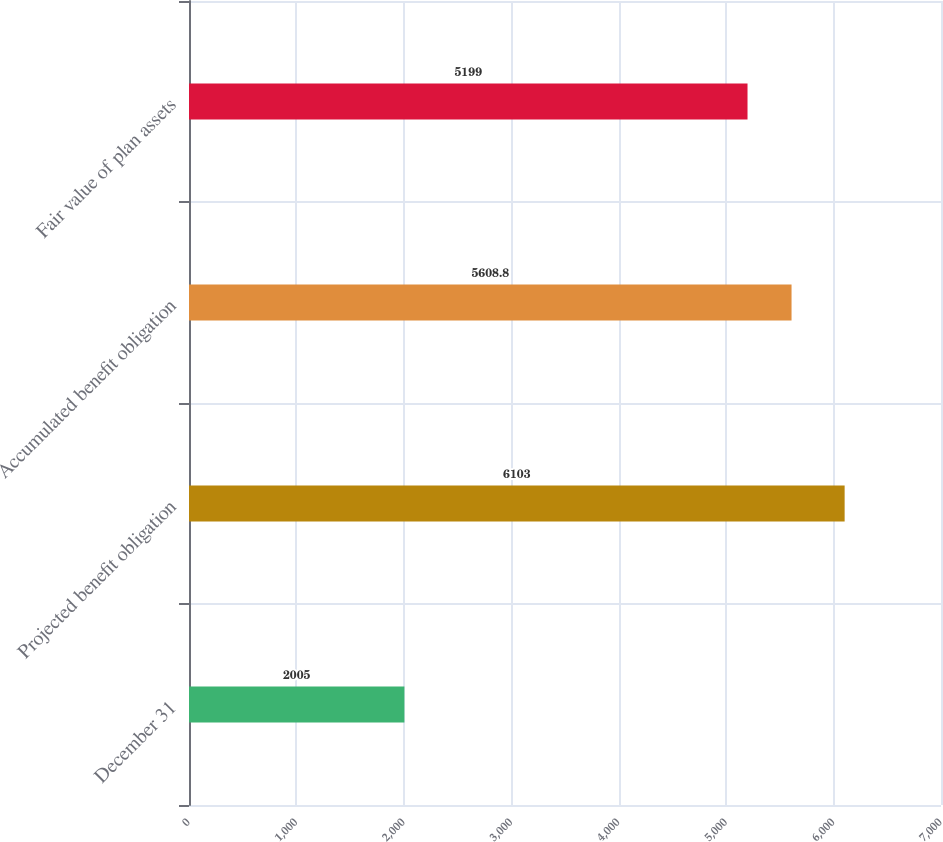Convert chart. <chart><loc_0><loc_0><loc_500><loc_500><bar_chart><fcel>December 31<fcel>Projected benefit obligation<fcel>Accumulated benefit obligation<fcel>Fair value of plan assets<nl><fcel>2005<fcel>6103<fcel>5608.8<fcel>5199<nl></chart> 